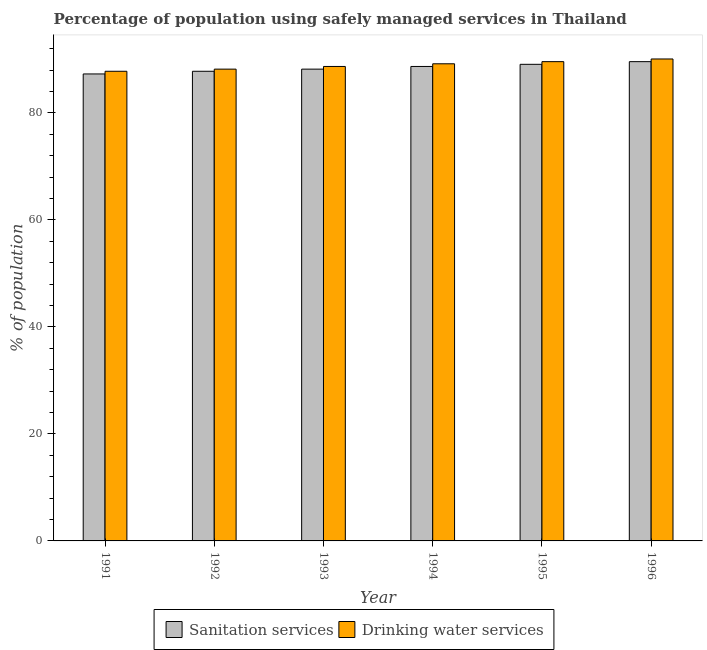How many groups of bars are there?
Make the answer very short. 6. How many bars are there on the 4th tick from the left?
Make the answer very short. 2. What is the label of the 5th group of bars from the left?
Provide a short and direct response. 1995. What is the percentage of population who used sanitation services in 1994?
Your answer should be very brief. 88.7. Across all years, what is the maximum percentage of population who used drinking water services?
Offer a terse response. 90.1. Across all years, what is the minimum percentage of population who used drinking water services?
Give a very brief answer. 87.8. In which year was the percentage of population who used drinking water services minimum?
Provide a short and direct response. 1991. What is the total percentage of population who used drinking water services in the graph?
Your answer should be compact. 533.6. What is the difference between the percentage of population who used drinking water services in 1991 and that in 1994?
Provide a short and direct response. -1.4. What is the difference between the percentage of population who used sanitation services in 1996 and the percentage of population who used drinking water services in 1995?
Offer a very short reply. 0.5. What is the average percentage of population who used sanitation services per year?
Give a very brief answer. 88.45. What is the ratio of the percentage of population who used drinking water services in 1994 to that in 1995?
Offer a very short reply. 1. Is the percentage of population who used drinking water services in 1992 less than that in 1994?
Give a very brief answer. Yes. What is the difference between the highest and the second highest percentage of population who used drinking water services?
Your answer should be compact. 0.5. What is the difference between the highest and the lowest percentage of population who used drinking water services?
Offer a very short reply. 2.3. In how many years, is the percentage of population who used sanitation services greater than the average percentage of population who used sanitation services taken over all years?
Provide a succinct answer. 3. Is the sum of the percentage of population who used sanitation services in 1993 and 1996 greater than the maximum percentage of population who used drinking water services across all years?
Make the answer very short. Yes. What does the 2nd bar from the left in 1994 represents?
Ensure brevity in your answer.  Drinking water services. What does the 1st bar from the right in 1994 represents?
Your answer should be very brief. Drinking water services. How many years are there in the graph?
Your answer should be very brief. 6. How many legend labels are there?
Your answer should be very brief. 2. How are the legend labels stacked?
Provide a short and direct response. Horizontal. What is the title of the graph?
Provide a short and direct response. Percentage of population using safely managed services in Thailand. What is the label or title of the Y-axis?
Provide a succinct answer. % of population. What is the % of population in Sanitation services in 1991?
Your answer should be compact. 87.3. What is the % of population of Drinking water services in 1991?
Ensure brevity in your answer.  87.8. What is the % of population of Sanitation services in 1992?
Your answer should be compact. 87.8. What is the % of population in Drinking water services in 1992?
Provide a succinct answer. 88.2. What is the % of population in Sanitation services in 1993?
Ensure brevity in your answer.  88.2. What is the % of population of Drinking water services in 1993?
Offer a terse response. 88.7. What is the % of population in Sanitation services in 1994?
Your answer should be compact. 88.7. What is the % of population of Drinking water services in 1994?
Provide a succinct answer. 89.2. What is the % of population in Sanitation services in 1995?
Keep it short and to the point. 89.1. What is the % of population of Drinking water services in 1995?
Give a very brief answer. 89.6. What is the % of population in Sanitation services in 1996?
Make the answer very short. 89.6. What is the % of population of Drinking water services in 1996?
Your answer should be compact. 90.1. Across all years, what is the maximum % of population of Sanitation services?
Make the answer very short. 89.6. Across all years, what is the maximum % of population in Drinking water services?
Make the answer very short. 90.1. Across all years, what is the minimum % of population in Sanitation services?
Make the answer very short. 87.3. Across all years, what is the minimum % of population in Drinking water services?
Your response must be concise. 87.8. What is the total % of population of Sanitation services in the graph?
Provide a succinct answer. 530.7. What is the total % of population of Drinking water services in the graph?
Give a very brief answer. 533.6. What is the difference between the % of population of Drinking water services in 1991 and that in 1992?
Your answer should be very brief. -0.4. What is the difference between the % of population of Sanitation services in 1991 and that in 1993?
Provide a succinct answer. -0.9. What is the difference between the % of population of Drinking water services in 1991 and that in 1994?
Your answer should be compact. -1.4. What is the difference between the % of population in Sanitation services in 1991 and that in 1995?
Ensure brevity in your answer.  -1.8. What is the difference between the % of population of Sanitation services in 1991 and that in 1996?
Ensure brevity in your answer.  -2.3. What is the difference between the % of population in Sanitation services in 1992 and that in 1993?
Give a very brief answer. -0.4. What is the difference between the % of population of Drinking water services in 1992 and that in 1993?
Give a very brief answer. -0.5. What is the difference between the % of population of Sanitation services in 1992 and that in 1994?
Keep it short and to the point. -0.9. What is the difference between the % of population of Sanitation services in 1992 and that in 1995?
Provide a short and direct response. -1.3. What is the difference between the % of population in Drinking water services in 1992 and that in 1995?
Give a very brief answer. -1.4. What is the difference between the % of population of Drinking water services in 1993 and that in 1994?
Give a very brief answer. -0.5. What is the difference between the % of population in Sanitation services in 1993 and that in 1995?
Offer a terse response. -0.9. What is the difference between the % of population in Drinking water services in 1993 and that in 1995?
Provide a short and direct response. -0.9. What is the difference between the % of population of Drinking water services in 1993 and that in 1996?
Give a very brief answer. -1.4. What is the difference between the % of population in Drinking water services in 1994 and that in 1996?
Give a very brief answer. -0.9. What is the difference between the % of population in Sanitation services in 1995 and that in 1996?
Make the answer very short. -0.5. What is the difference between the % of population of Sanitation services in 1991 and the % of population of Drinking water services in 1992?
Provide a succinct answer. -0.9. What is the difference between the % of population of Sanitation services in 1991 and the % of population of Drinking water services in 1994?
Ensure brevity in your answer.  -1.9. What is the difference between the % of population of Sanitation services in 1991 and the % of population of Drinking water services in 1995?
Make the answer very short. -2.3. What is the difference between the % of population in Sanitation services in 1991 and the % of population in Drinking water services in 1996?
Offer a terse response. -2.8. What is the difference between the % of population in Sanitation services in 1992 and the % of population in Drinking water services in 1994?
Give a very brief answer. -1.4. What is the difference between the % of population in Sanitation services in 1992 and the % of population in Drinking water services in 1996?
Make the answer very short. -2.3. What is the difference between the % of population in Sanitation services in 1993 and the % of population in Drinking water services in 1995?
Provide a succinct answer. -1.4. What is the difference between the % of population in Sanitation services in 1994 and the % of population in Drinking water services in 1995?
Provide a short and direct response. -0.9. What is the difference between the % of population of Sanitation services in 1994 and the % of population of Drinking water services in 1996?
Your answer should be compact. -1.4. What is the difference between the % of population of Sanitation services in 1995 and the % of population of Drinking water services in 1996?
Keep it short and to the point. -1. What is the average % of population in Sanitation services per year?
Keep it short and to the point. 88.45. What is the average % of population in Drinking water services per year?
Provide a short and direct response. 88.93. In the year 1993, what is the difference between the % of population of Sanitation services and % of population of Drinking water services?
Your answer should be compact. -0.5. In the year 1994, what is the difference between the % of population in Sanitation services and % of population in Drinking water services?
Provide a succinct answer. -0.5. In the year 1995, what is the difference between the % of population in Sanitation services and % of population in Drinking water services?
Your answer should be compact. -0.5. In the year 1996, what is the difference between the % of population in Sanitation services and % of population in Drinking water services?
Offer a very short reply. -0.5. What is the ratio of the % of population in Sanitation services in 1991 to that in 1992?
Your answer should be very brief. 0.99. What is the ratio of the % of population of Drinking water services in 1991 to that in 1992?
Offer a very short reply. 1. What is the ratio of the % of population in Drinking water services in 1991 to that in 1993?
Provide a short and direct response. 0.99. What is the ratio of the % of population in Sanitation services in 1991 to that in 1994?
Give a very brief answer. 0.98. What is the ratio of the % of population of Drinking water services in 1991 to that in 1994?
Offer a terse response. 0.98. What is the ratio of the % of population in Sanitation services in 1991 to that in 1995?
Your answer should be very brief. 0.98. What is the ratio of the % of population of Drinking water services in 1991 to that in 1995?
Provide a short and direct response. 0.98. What is the ratio of the % of population of Sanitation services in 1991 to that in 1996?
Ensure brevity in your answer.  0.97. What is the ratio of the % of population of Drinking water services in 1991 to that in 1996?
Give a very brief answer. 0.97. What is the ratio of the % of population of Sanitation services in 1992 to that in 1994?
Your answer should be very brief. 0.99. What is the ratio of the % of population in Drinking water services in 1992 to that in 1994?
Ensure brevity in your answer.  0.99. What is the ratio of the % of population of Sanitation services in 1992 to that in 1995?
Provide a short and direct response. 0.99. What is the ratio of the % of population in Drinking water services in 1992 to that in 1995?
Provide a succinct answer. 0.98. What is the ratio of the % of population of Sanitation services in 1992 to that in 1996?
Your answer should be compact. 0.98. What is the ratio of the % of population in Drinking water services in 1992 to that in 1996?
Offer a terse response. 0.98. What is the ratio of the % of population in Sanitation services in 1993 to that in 1994?
Offer a very short reply. 0.99. What is the ratio of the % of population of Drinking water services in 1993 to that in 1994?
Provide a succinct answer. 0.99. What is the ratio of the % of population in Sanitation services in 1993 to that in 1996?
Offer a very short reply. 0.98. What is the ratio of the % of population of Drinking water services in 1993 to that in 1996?
Make the answer very short. 0.98. What is the ratio of the % of population of Sanitation services in 1994 to that in 1995?
Your answer should be very brief. 1. What is the ratio of the % of population in Drinking water services in 1995 to that in 1996?
Provide a short and direct response. 0.99. What is the difference between the highest and the second highest % of population in Sanitation services?
Your response must be concise. 0.5. What is the difference between the highest and the lowest % of population of Sanitation services?
Offer a very short reply. 2.3. What is the difference between the highest and the lowest % of population of Drinking water services?
Provide a succinct answer. 2.3. 